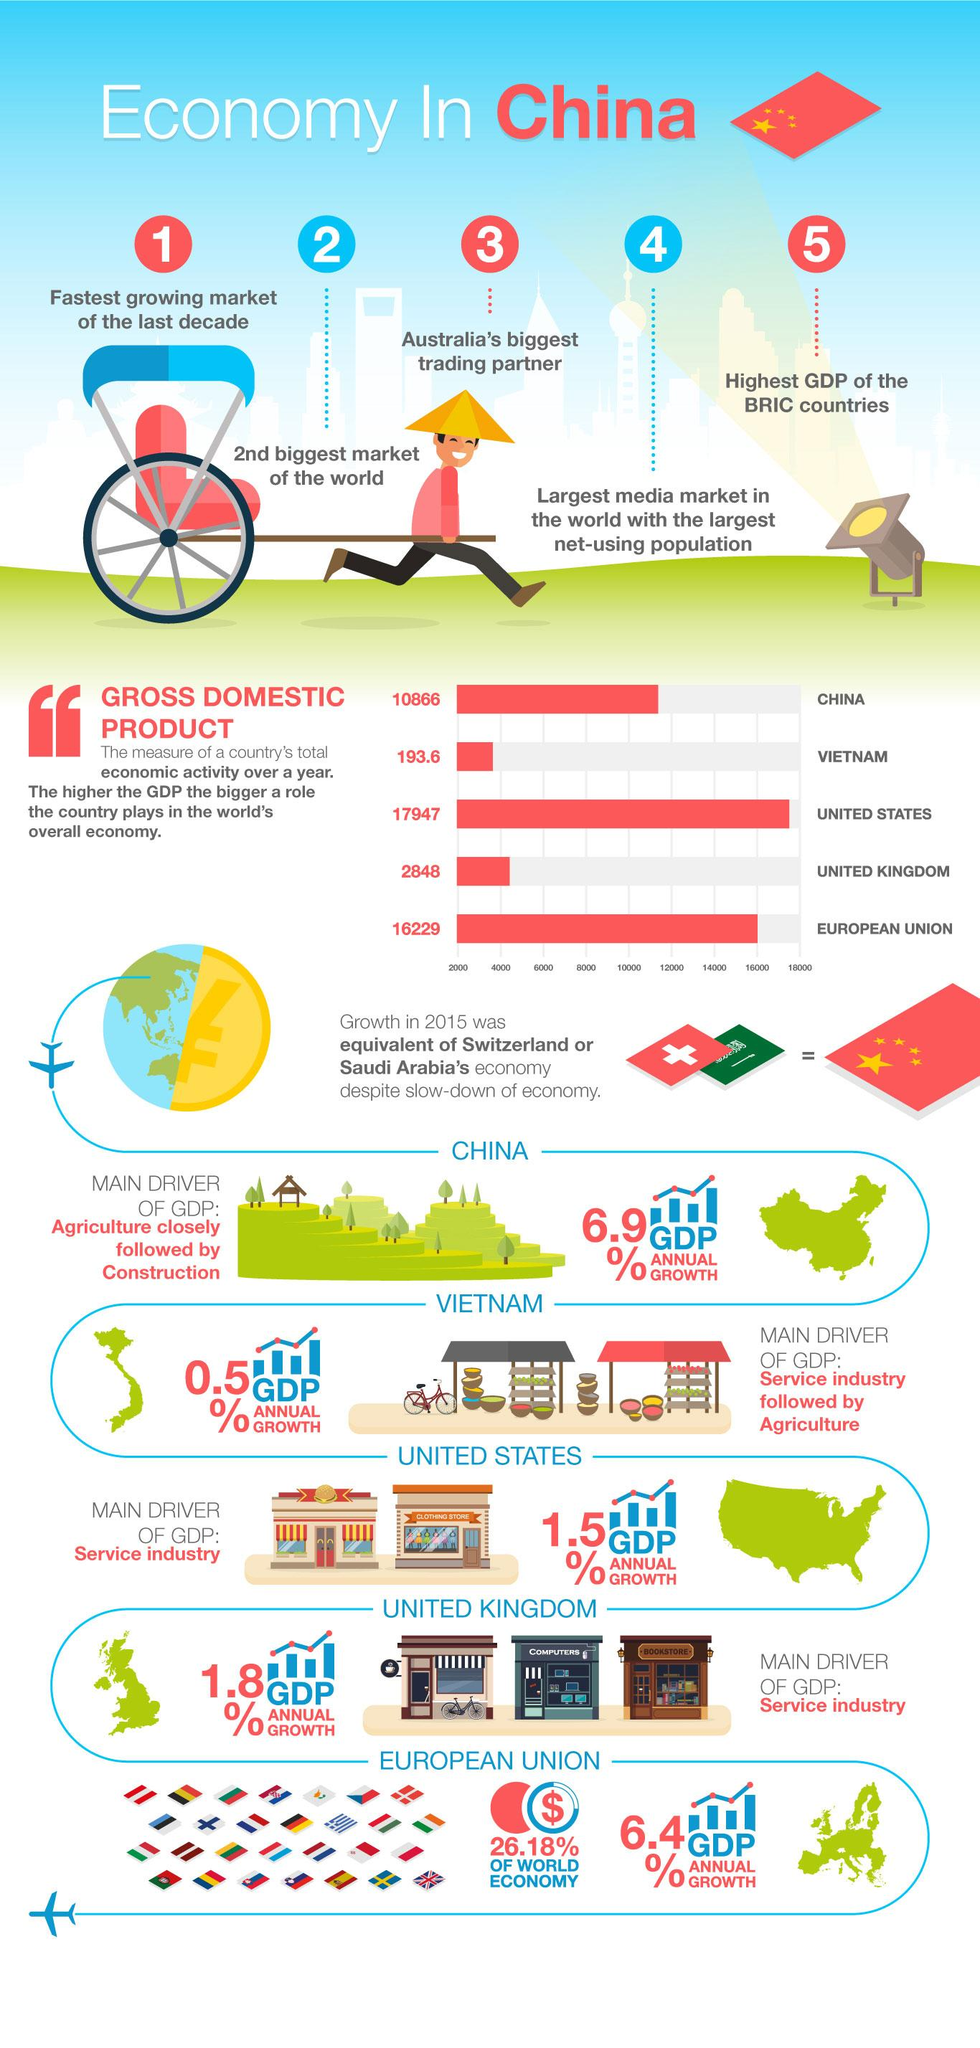Point out several critical features in this image. The United Kingdom comes in fourth in its contribution to the World's overall economy. According to the annual growth of GDP of China, the agricultural industry made the most significant contribution. According to recent estimates, China is the third country in terms of its contribution to the global economy. In 2015, economic growth in China was substantially higher than that of Switzerland and Saudi Arabia, which were two of its key trading partners. The service industry was the driving force behind the annual growth of the United Kingdom's Gross Domestic Product (GDP). 